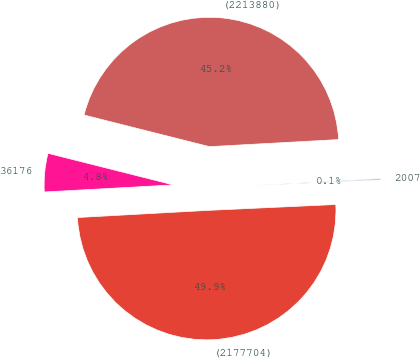Convert chart. <chart><loc_0><loc_0><loc_500><loc_500><pie_chart><fcel>2007<fcel>(2213880)<fcel>36176<fcel>(2177704)<nl><fcel>0.14%<fcel>45.2%<fcel>4.8%<fcel>49.86%<nl></chart> 